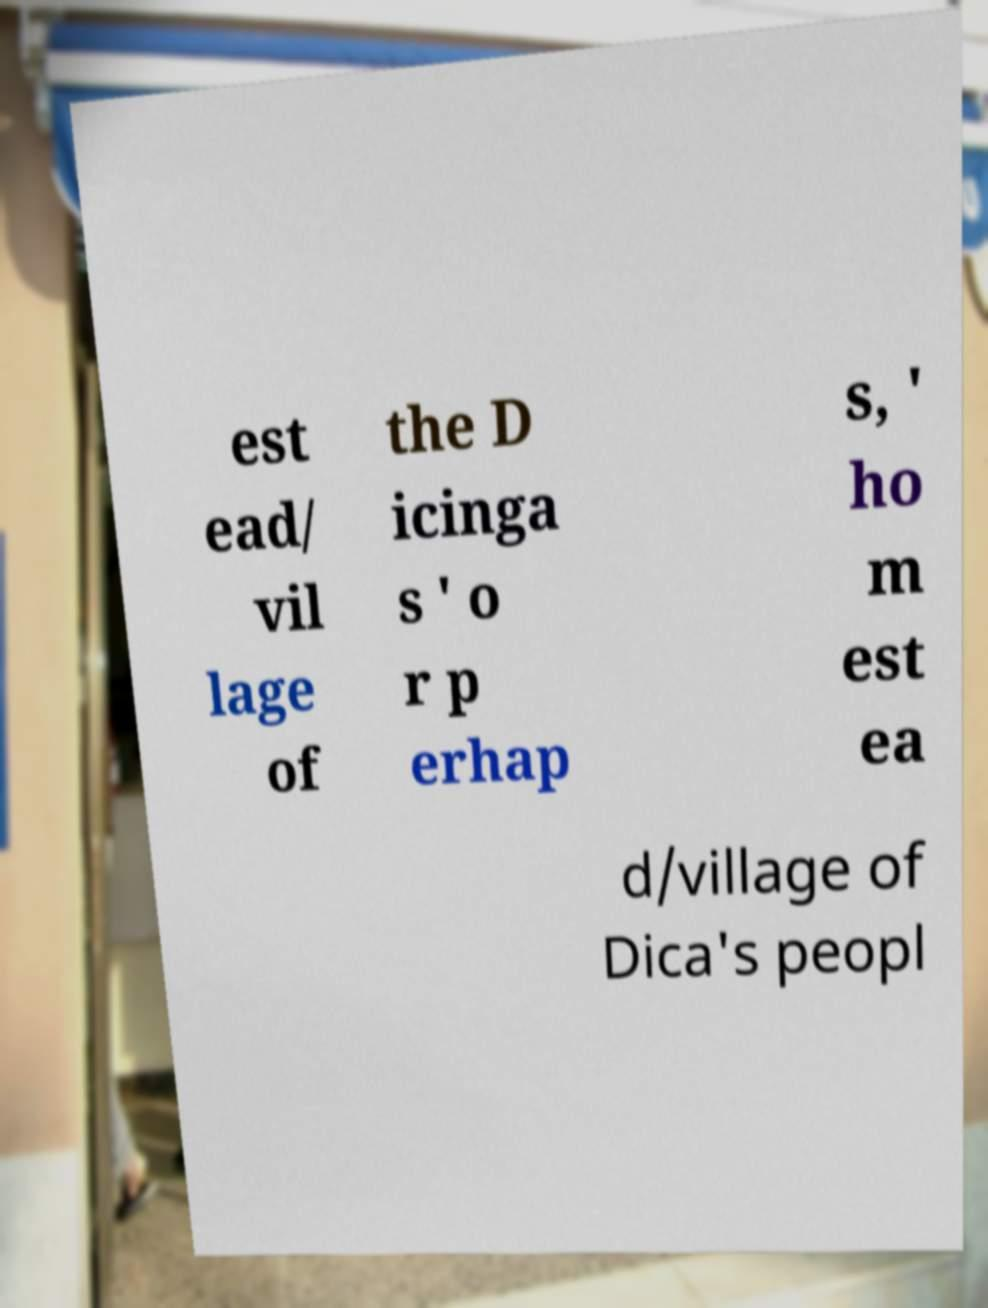Please read and relay the text visible in this image. What does it say? est ead/ vil lage of the D icinga s ' o r p erhap s, ' ho m est ea d/village of Dica's peopl 